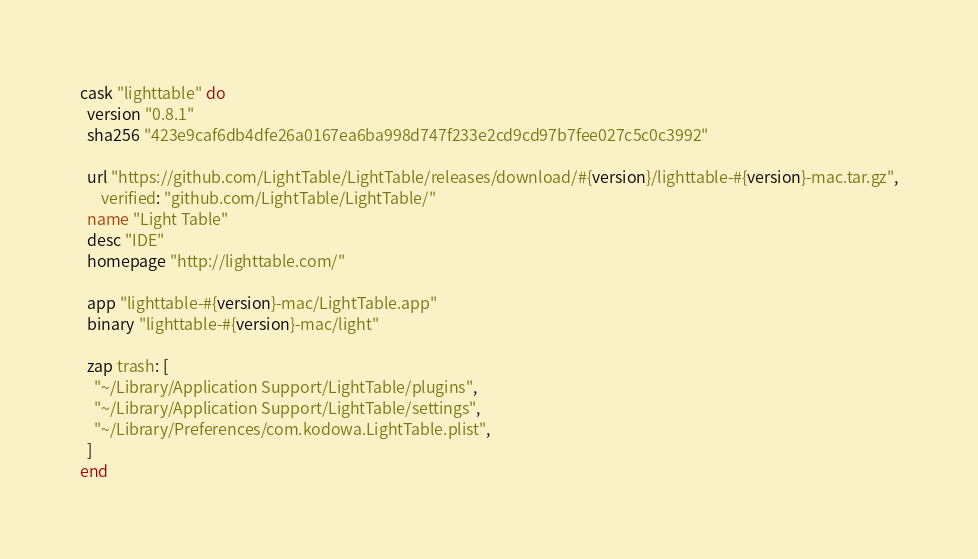Convert code to text. <code><loc_0><loc_0><loc_500><loc_500><_Ruby_>cask "lighttable" do
  version "0.8.1"
  sha256 "423e9caf6db4dfe26a0167ea6ba998d747f233e2cd9cd97b7fee027c5c0c3992"

  url "https://github.com/LightTable/LightTable/releases/download/#{version}/lighttable-#{version}-mac.tar.gz",
      verified: "github.com/LightTable/LightTable/"
  name "Light Table"
  desc "IDE"
  homepage "http://lighttable.com/"

  app "lighttable-#{version}-mac/LightTable.app"
  binary "lighttable-#{version}-mac/light"

  zap trash: [
    "~/Library/Application Support/LightTable/plugins",
    "~/Library/Application Support/LightTable/settings",
    "~/Library/Preferences/com.kodowa.LightTable.plist",
  ]
end
</code> 